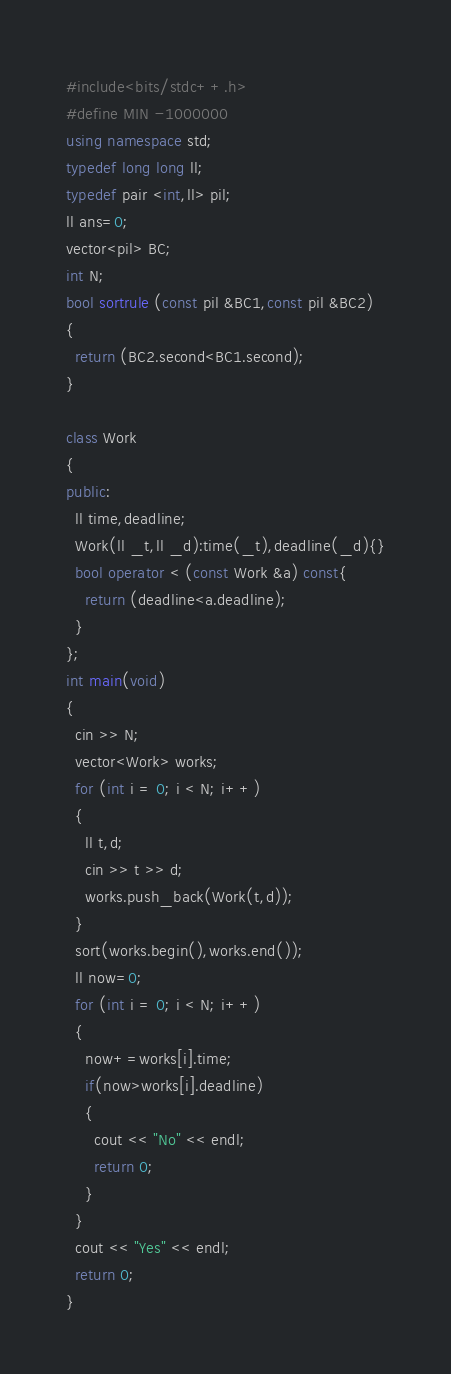Convert code to text. <code><loc_0><loc_0><loc_500><loc_500><_C++_>#include<bits/stdc++.h>
#define MIN -1000000
using namespace std;
typedef long long ll;
typedef pair <int,ll> pil;
ll ans=0;
vector<pil> BC;
int N;
bool sortrule (const pil &BC1,const pil &BC2)
{
  return (BC2.second<BC1.second);
}

class Work
{
public:
  ll time,deadline;
  Work(ll _t,ll _d):time(_t),deadline(_d){}
  bool operator < (const Work &a) const{
    return (deadline<a.deadline);
  }
};
int main(void)
{
  cin >> N;
  vector<Work> works;
  for (int i = 0; i < N; i++)
  {
    ll t,d;
    cin >> t >> d;
    works.push_back(Work(t,d));
  }
  sort(works.begin(),works.end());
  ll now=0;
  for (int i = 0; i < N; i++)
  {
    now+=works[i].time;
    if(now>works[i].deadline)
    {
      cout << "No" << endl;
      return 0;
    }
  }
  cout << "Yes" << endl;
  return 0;
}
</code> 